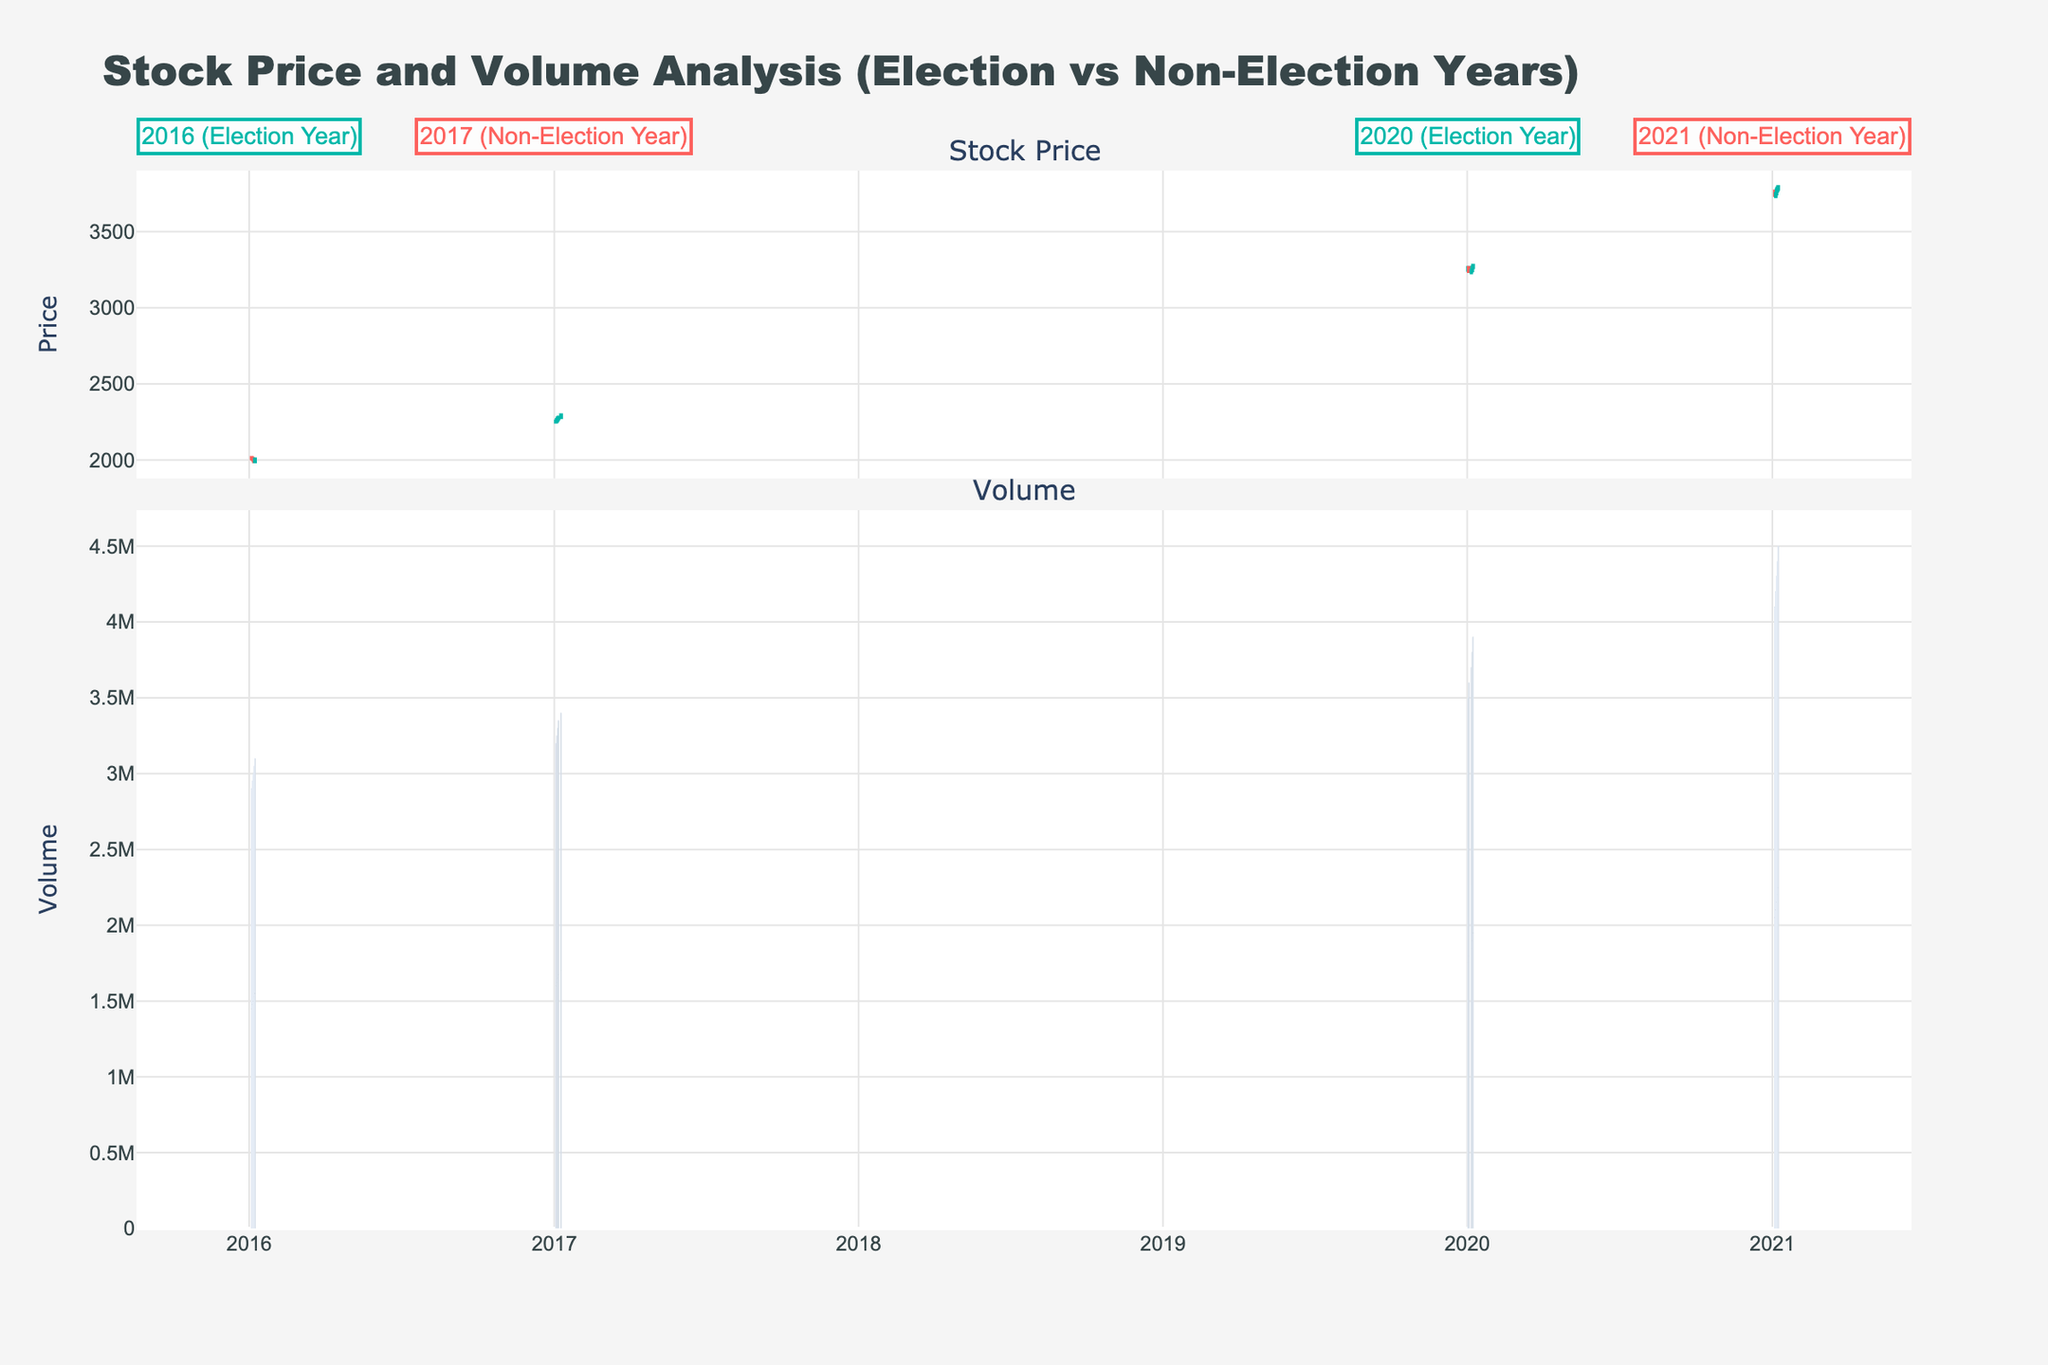How does the stock price trend differ between election years and non-election years? By examining the candlestick plot, we can observe that in the election years, particularly 2016 and 2020, there is noticeable volatility with significant swings in the stock prices within the first few days. In contrast, non-election years like 2017 and 2021 show a more steady increase in stock prices over the same time period.
Answer: Election years show more volatility, non-election years show a steadier increase What are the overall stock price patterns in the election years 2016 and 2020? In the election years 2016 and 2020, the stock prices exhibit significant fluctuations. In both years, the prices start relatively high, then drop noticeably within a couple of days before experiencing slight recoveries. This oscillation reflects the uncertainty commonly associated with election periods.
Answer: Significant fluctuations with initial drops followed by slight recoveries How does the trading volume in election years compare to non-election years? From the volume bar chart in the figure, we see that trading volumes tend to be higher in non-election years (2017 and 2021) compared to election years (2016 and 2020). In non-election years, trading volumes consistently increase over the days, indicating growing market activity.
Answer: Non-election years have higher trading volumes Which year shows the greatest stock price increase over the first few days? Analyzing the candlesticks, the non-election year 2021 shows the most significant stock price increase within the first few days. The prices move progressively higher each day, from around 3765 to 3795.
Answer: 2021 What is the trend in stock prices for the non-election year 2021 compared to 2017? Both non-election years 2021 and 2017 demonstrate an increasing trend in stock prices over the days. However, 2021 exhibits a more pronounced and steady upward movement, while 2017 shows smaller, incremental increases with minor fluctuations.
Answer: 2021 shows a more pronounced and steady increase compared to 2017 How does the color-coding of the candlestick plot help differentiate between increasing and decreasing days? The color-coding in the candlestick plot uses green for days when the closing price was higher than the opening price (increasing days) and red for days when the closing price was lower than the opening price (decreasing days). This visual differentiation helps quickly identify the trend for each day.
Answer: Green for increasing, red for decreasing Which year had the highest trading volume on any single day? By examining the bar chart of trading volumes, we see that 2021, a non-election year, had the highest trading volume on January 8, with a volume of 4,500,000.
Answer: 2021 on January 8 What is the common trend in stock prices during the first week of January in election years based on the given data? In the election years 2016 and 2020, the stock prices initially rise but then experience sharp declines within the first week of January, indicating market volatility during election periods.
Answer: Initial rise followed by sharp declines Across all given years, how does the first trading day's closing price compare to the last trading day's closing price? For election years: 2016 (2010 to around 2005), 2020 (3263 to 3278). For non-election years: 2017 (2255 to 2295), 2021 (3740 to 3795). Both non-election years show an overall increase from the first to the last trading day, while election years show mixed results with 2020 increasing and 2016 decreasing.
Answer: Non-election years generally show an increase On which days were the largest upward price movements observed? The largest upward price movements are observed on January 8 of both 2020 and 2021. In 2020, the price moved significantly higher, and in 2021, there was a steady upward movement until January 8. Both these days are characterized by longer bodies of green candlesticks, indicating substantial gains.
Answer: January 8 in 2020 and 2021 